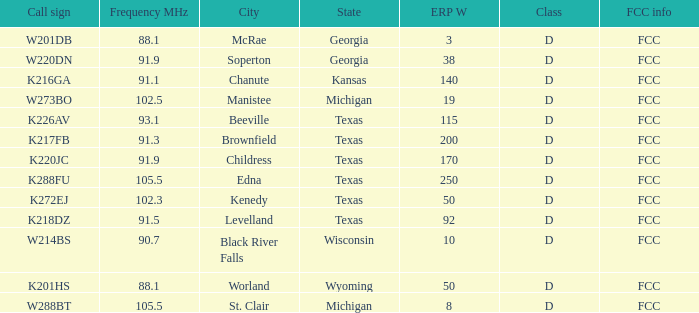What is Call Sign, when ERP W is greater than 50? K216GA, K226AV, K217FB, K220JC, K288FU, K218DZ. 